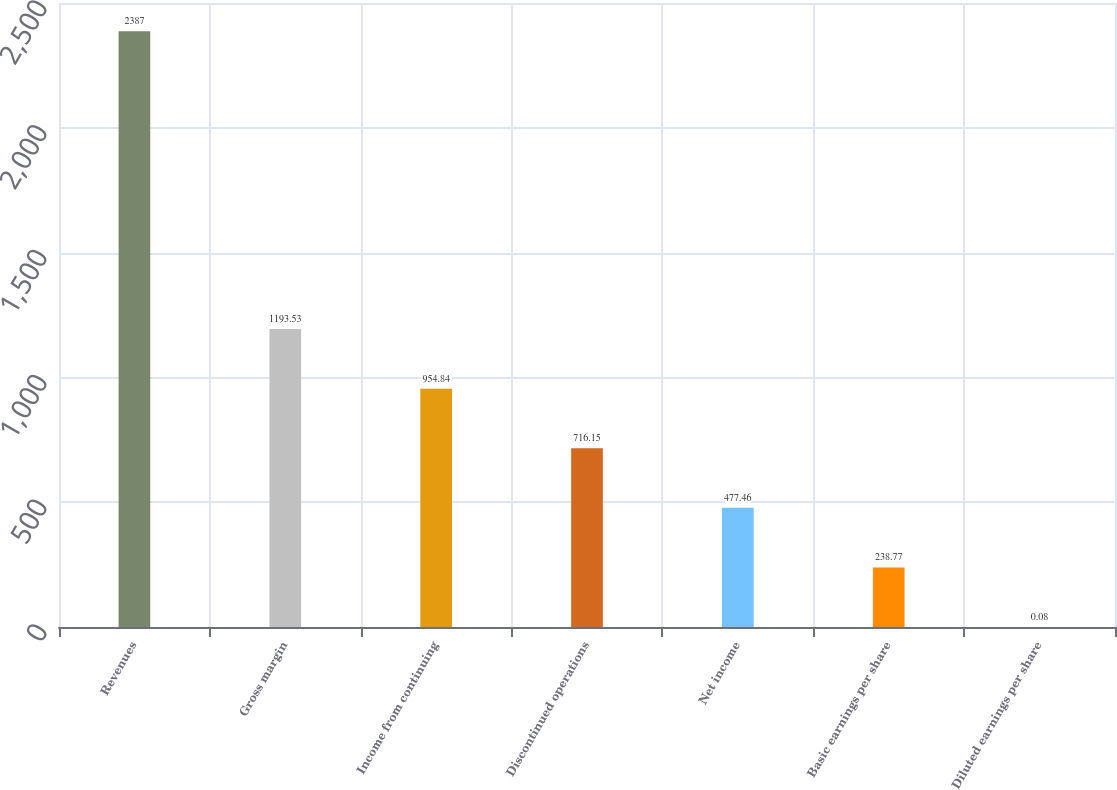Convert chart. <chart><loc_0><loc_0><loc_500><loc_500><bar_chart><fcel>Revenues<fcel>Gross margin<fcel>Income from continuing<fcel>Discontinued operations<fcel>Net income<fcel>Basic earnings per share<fcel>Diluted earnings per share<nl><fcel>2387<fcel>1193.53<fcel>954.84<fcel>716.15<fcel>477.46<fcel>238.77<fcel>0.08<nl></chart> 